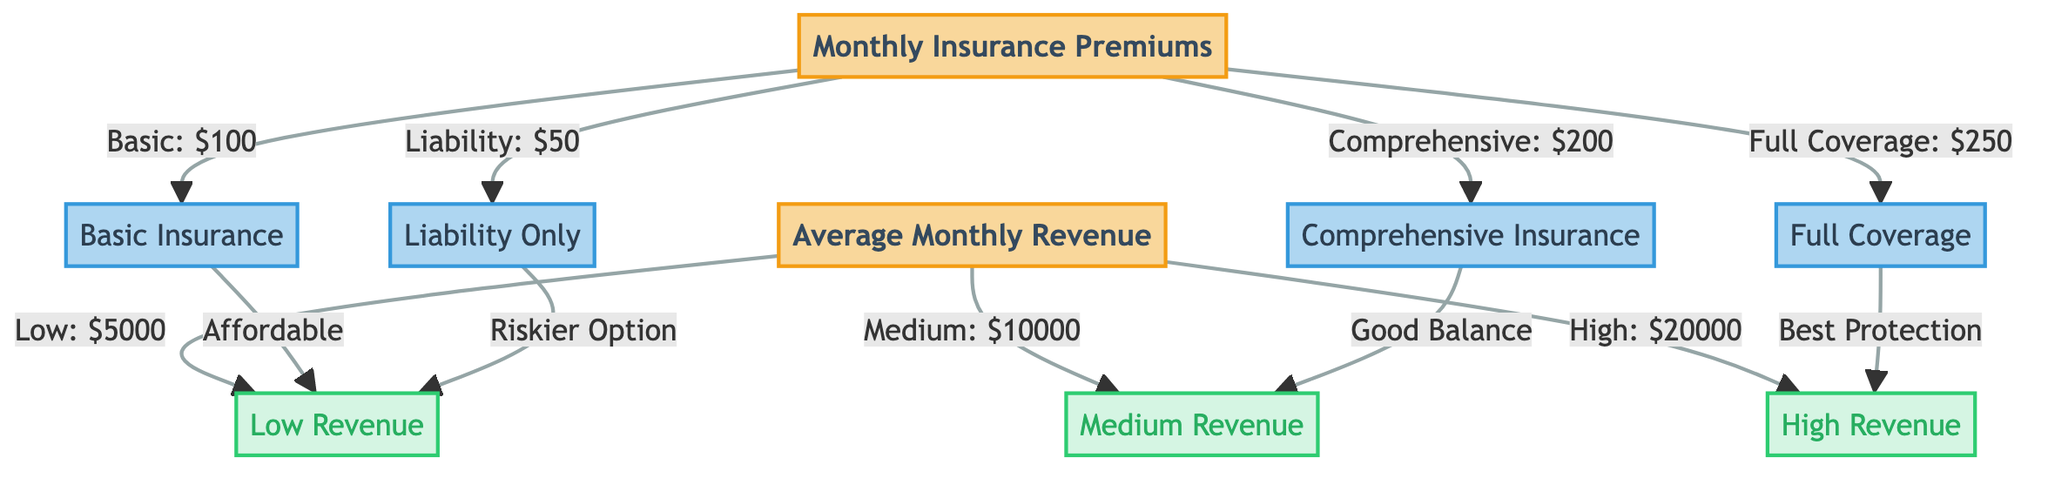What's the monthly premium for Comprehensive Insurance? The diagram states that the Monthly Insurance Premium for Comprehensive Insurance is $200.
Answer: $200 What is the average monthly revenue for a food truck with low revenue? According to the diagram, the Average Monthly Revenue for low revenue is $5000.
Answer: $5000 How many insurance options are listed in the diagram? The diagram presents four types of insurance options: Basic, Comprehensive, Liability Only, and Full Coverage, which totals four options.
Answer: 4 Which insurance option is associated with the best protection? The diagram indicates that Full Coverage is labeled as "Best Protection" under the insurance options.
Answer: Full Coverage What average monthly revenue level is linked to a good balance according to the diagram? The diagram specifies that Comprehensive Insurance, which is described as having a "Good Balance," is linked to a medium average monthly revenue level of $10000.
Answer: $10000 If a food truck has high revenue, which insurance option offers the best protection? The diagram shows that if a food truck experiences high revenue, the Full Coverage insurance option is the one that provides the best protection.
Answer: Full Coverage What kind of insurance is related to a risky option? The diagram labels Liability Only insurance as a "Riskier Option," aligning it with that category.
Answer: Liability Only Which average monthly revenue tier is linked to the Basic Insurance option? The diagram connects Basic Insurance with low revenue, indicating that it is an affordable choice for food trucks in that revenue tier.
Answer: Low Revenue Which insurance option has the lowest monthly premium? The diagram indicates that the Liability Only insurance option has the lowest monthly premium at $50.
Answer: Liability Only 